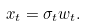Convert formula to latex. <formula><loc_0><loc_0><loc_500><loc_500>x _ { t } = \sigma _ { t } w _ { t } .</formula> 